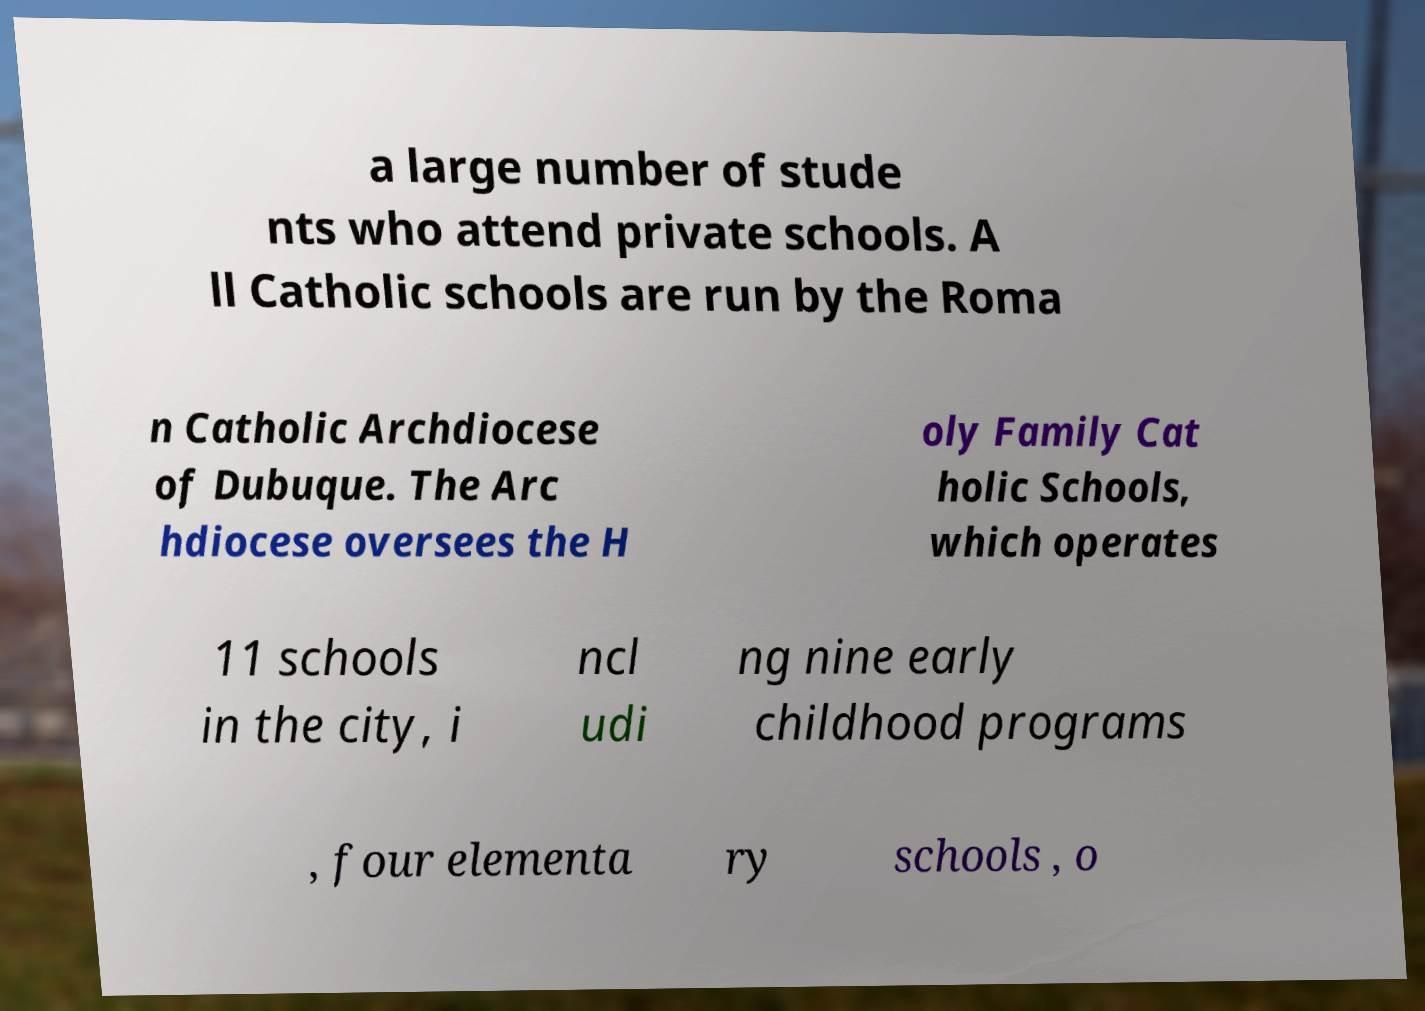Could you assist in decoding the text presented in this image and type it out clearly? a large number of stude nts who attend private schools. A ll Catholic schools are run by the Roma n Catholic Archdiocese of Dubuque. The Arc hdiocese oversees the H oly Family Cat holic Schools, which operates 11 schools in the city, i ncl udi ng nine early childhood programs , four elementa ry schools , o 